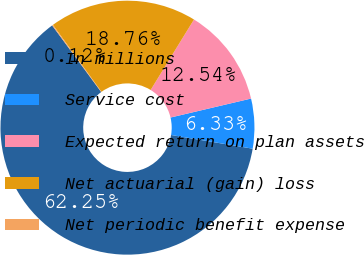Convert chart to OTSL. <chart><loc_0><loc_0><loc_500><loc_500><pie_chart><fcel>In millions<fcel>Service cost<fcel>Expected return on plan assets<fcel>Net actuarial (gain) loss<fcel>Net periodic benefit expense<nl><fcel>62.25%<fcel>6.33%<fcel>12.54%<fcel>18.76%<fcel>0.12%<nl></chart> 